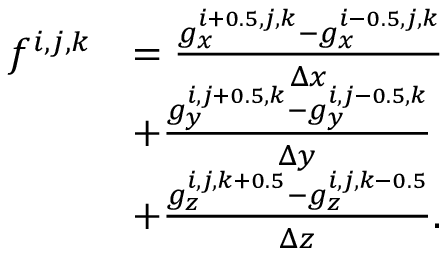Convert formula to latex. <formula><loc_0><loc_0><loc_500><loc_500>\begin{array} { r l } { f ^ { i , j , k } } & { = \frac { g _ { x } ^ { i + 0 . 5 , j , k } - g _ { x } ^ { i - 0 . 5 , j , k } } { \Delta x } } \\ & { + \frac { g _ { y } ^ { i , j + 0 . 5 , k } - g _ { y } ^ { i , j - 0 . 5 , k } } { \Delta y } } \\ & { + \frac { g _ { z } ^ { i , j , k + 0 . 5 } - g _ { z } ^ { i , j , k - 0 . 5 } } { \Delta z } . } \end{array}</formula> 